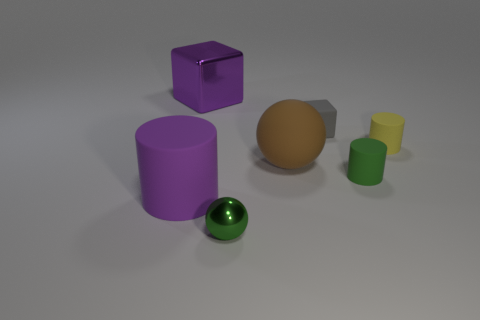Add 2 brown cubes. How many objects exist? 9 Subtract all cylinders. How many objects are left? 4 Subtract 0 red balls. How many objects are left? 7 Subtract all tiny green metallic cylinders. Subtract all big rubber things. How many objects are left? 5 Add 5 large blocks. How many large blocks are left? 6 Add 2 big red balls. How many big red balls exist? 2 